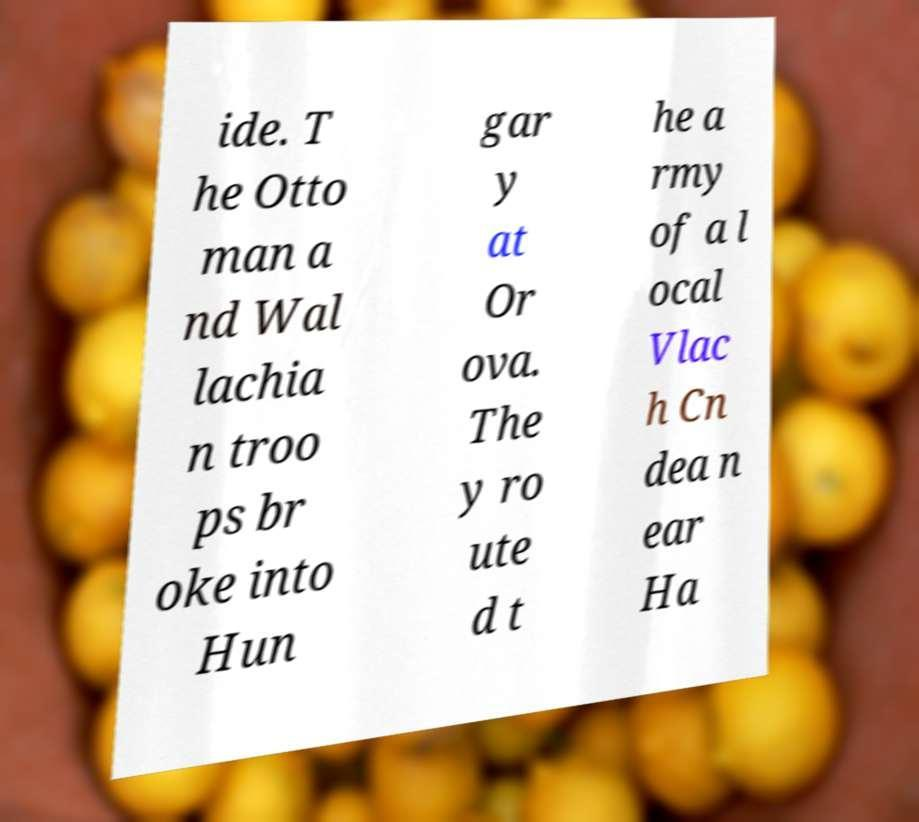For documentation purposes, I need the text within this image transcribed. Could you provide that? ide. T he Otto man a nd Wal lachia n troo ps br oke into Hun gar y at Or ova. The y ro ute d t he a rmy of a l ocal Vlac h Cn dea n ear Ha 